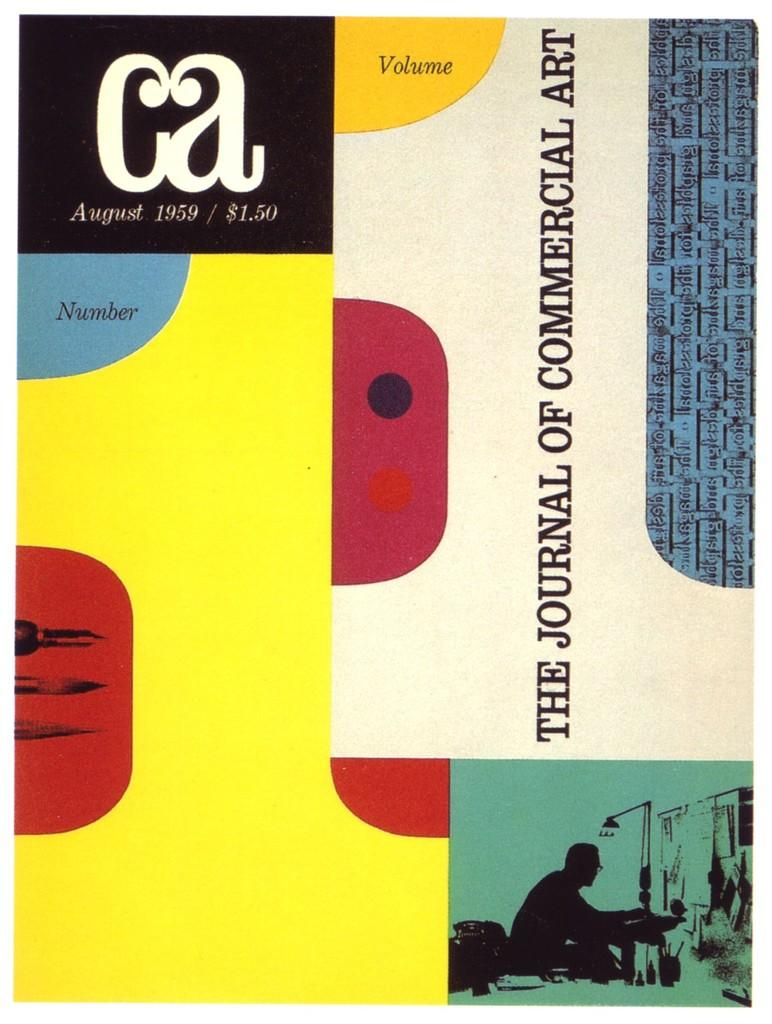What type of image is being described? The image is a graphic edited image. Where are the texts located in the image? The texts are on the right side top corner of the image. What can be found on the left side of the image? There are color shapes on the left side of the image. Are there any elements present at the bottom of the image? Yes, both texts and color shapes are present on the bottom of the image. What type of bushes can be seen in the image? There are no bushes present in the image; it is a graphic edited image with texts and color shapes. Can you tell me which country the secretary is from in the image? There is no secretary or country mentioned in the image; it only contains texts and color shapes. 